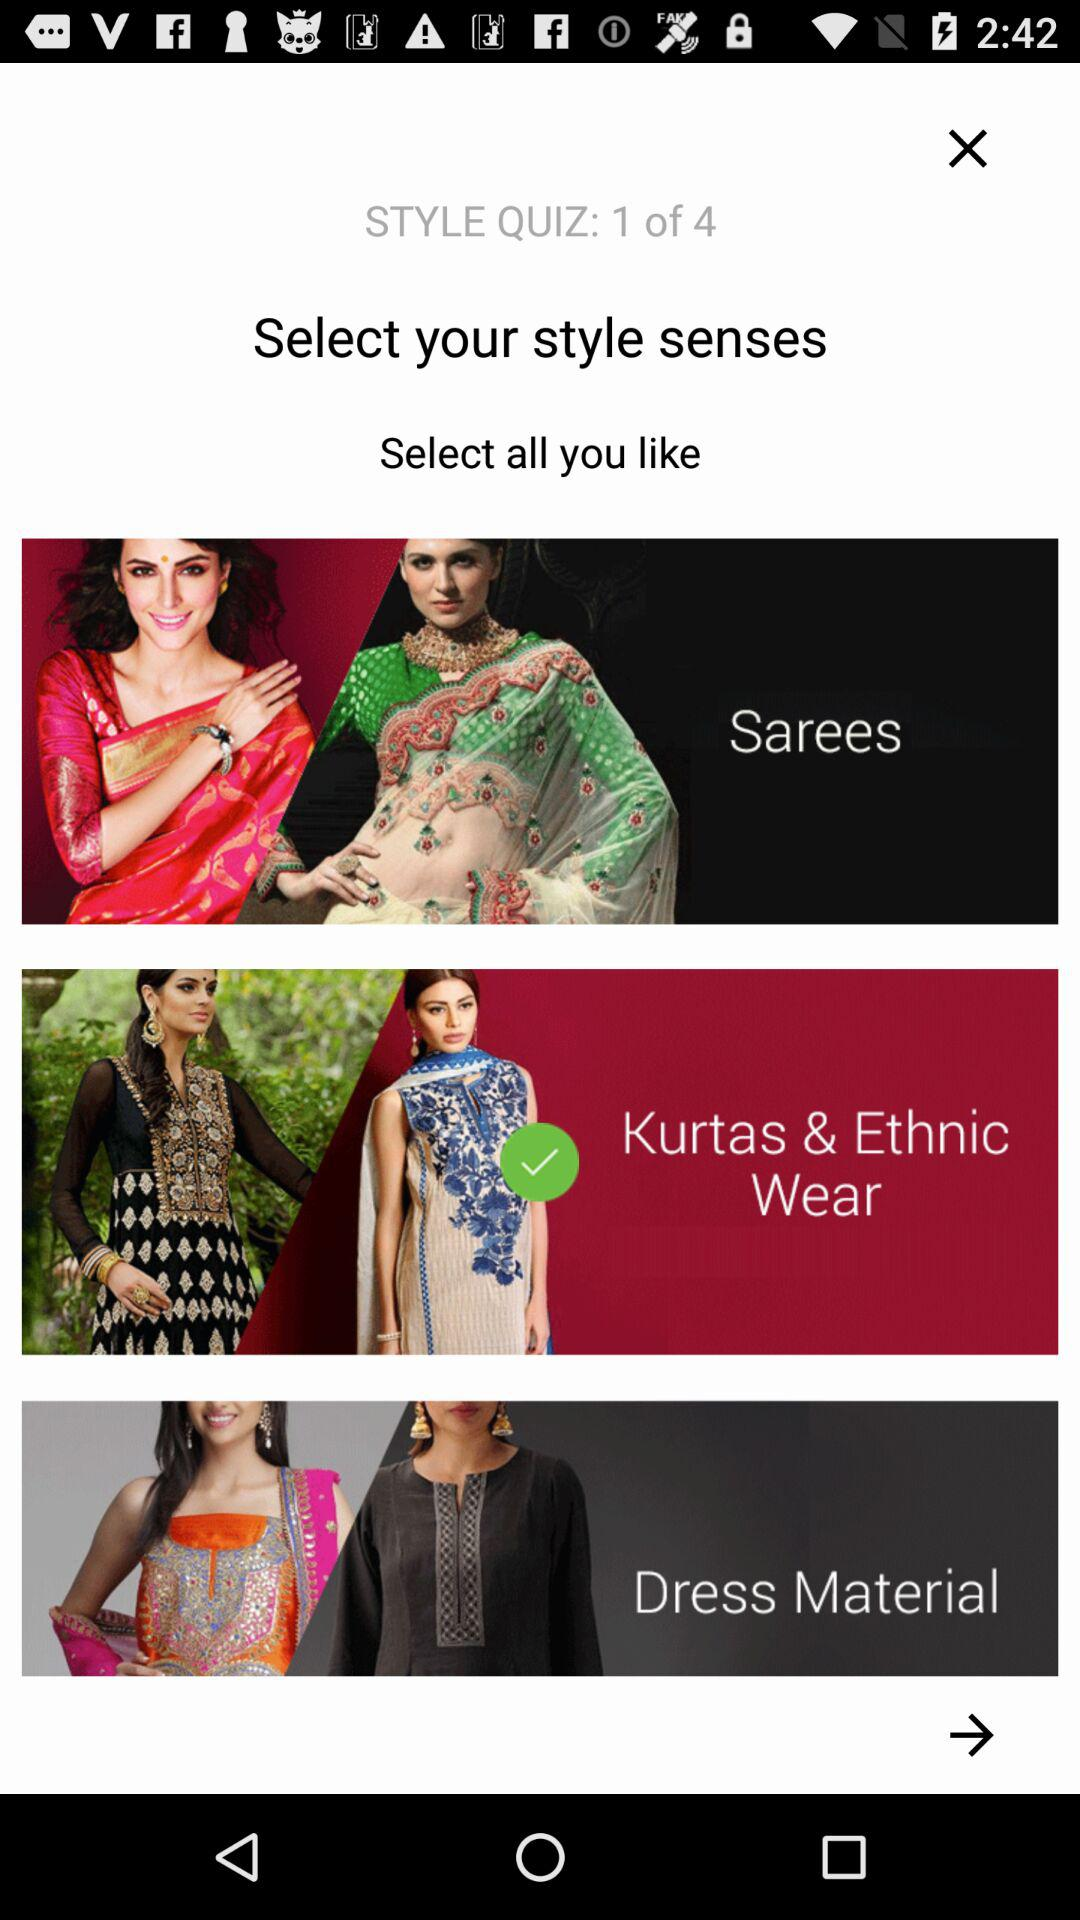Which type of dress is selected? The selected dress type is "Kurtas & Ethnic Wear". 